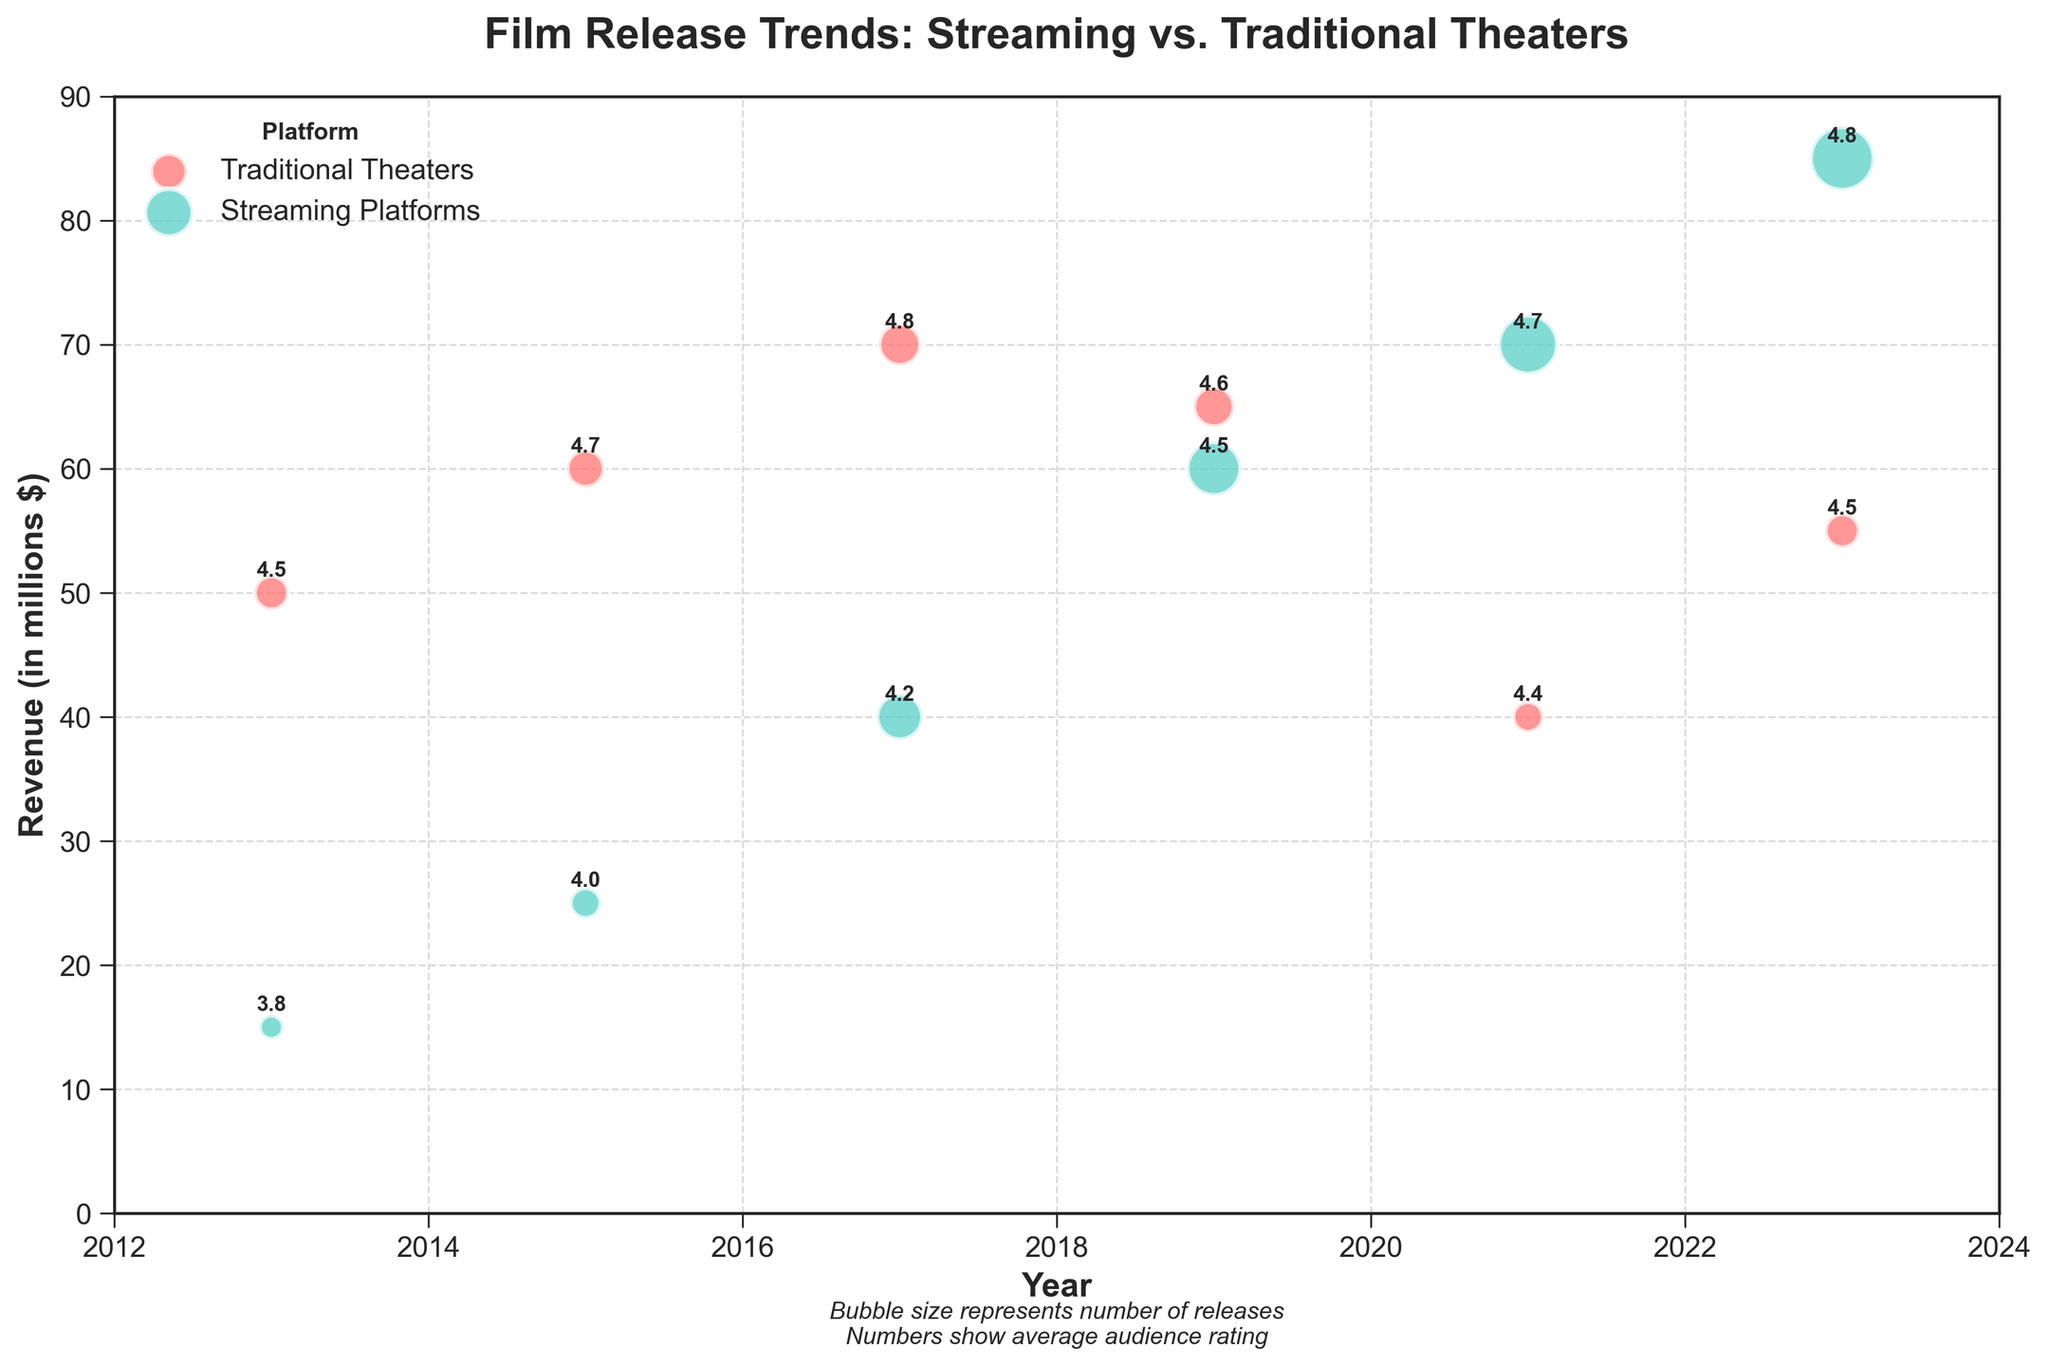How many different years are represented in the bubble chart? The x-axis of the bubble chart shows the years represented. By counting the different labels on the x-axis, we can determine the number of unique years.
Answer: 6 What are the colors used to differentiate between Traditional Theaters and Streaming Platforms? By looking at the legend on the top left of the chart, we can see that Traditional Theaters are colored in red, while Streaming Platforms are colored in teal.
Answer: Red and Teal How does the revenue trend for Traditional Theaters change from 2013 to 2023? Observing the y-axis values for Traditional Theaters (red bubbles) from 2013 to 2023, we see that the revenue starts at 50 in 2013, peaks at 70 in 2017, dips to 40 in 2021, and then rises again to 55 in 2023.
Answer: It fluctuates: rises, peaks, dips, rises again Which platform had the most significant increase in the number of releases from 2013 to 2023? By comparing the size of the bubbles (number of releases) for 2013 and 2023 for both platforms, it's evident that Streaming Platforms (teal bubbles) grew from 5 to 35, a more significant increase than Traditional Theaters.
Answer: Streaming Platforms In which year did Streaming Platforms surpass Traditional Theaters in revenue, based on the visual trend? Checking the y-axis values for both platforms over the years, Streaming Platforms surpass Traditional Theaters in revenue in 2019 and continue to do so in 2021 and 2023.
Answer: 2019 Compare the average audience rating for films released on Streaming Platforms in 2013 with 2023. Annotating the bubbles for Streaming Platforms (teal) in 2013 and 2023 shows the average audience ratings of 3.8 and 4.8 respectively.
Answer: 3.8 in 2013 to 4.8 in 2023 Which platform had higher average audience ratings in 2021, and by how much? Looking at the annotations for 2021, Traditional Theaters have an average rating of 4.4, and Streaming Platforms have 4.7. The difference is 4.7 - 4.4 = 0.3.
Answer: Streaming Platforms by 0.3 What is the general trend in the investment for Streaming Platforms from 2013 to 2023? Observing the size of the teal bubbles over the years, we see an upward trend, indicating an increasing number of releases (investment) from 2013 to 2023.
Answer: Increasing trend How does the number of releases for Traditional Theaters in 2019 compare to that in 2021? The size of the red bubbles in 2019 (14 releases) compared to 2021 (8 releases) shows a decrease.
Answer: Decreased What year had the highest number of releases on Streaming Platforms, and what was the average audience rating that year? The largest teal bubble corresponds to 2023, indicating the highest number of releases. The annotation inside the bubble shows an average audience rating of 4.8.
Answer: 2023, with a rating of 4.8 